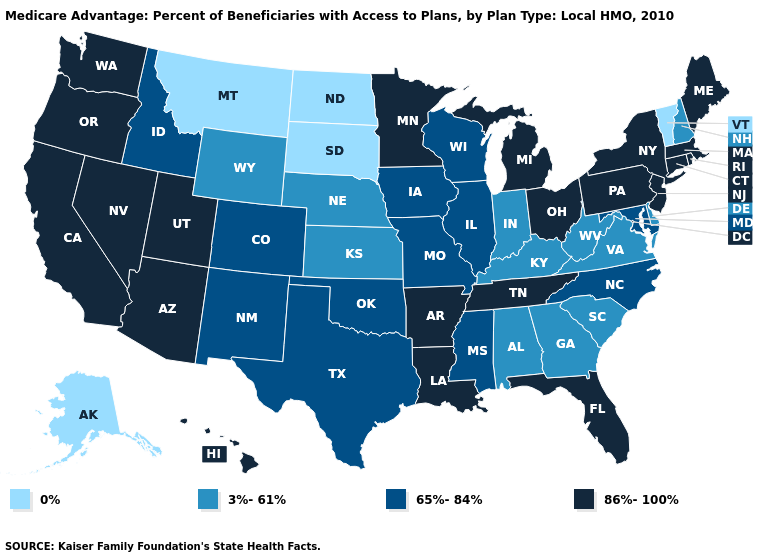Does Kansas have the lowest value in the MidWest?
Answer briefly. No. What is the highest value in states that border Rhode Island?
Quick response, please. 86%-100%. Does Kentucky have the same value as Iowa?
Write a very short answer. No. What is the value of Delaware?
Be succinct. 3%-61%. How many symbols are there in the legend?
Keep it brief. 4. Is the legend a continuous bar?
Quick response, please. No. Which states hav the highest value in the MidWest?
Short answer required. Michigan, Minnesota, Ohio. Name the states that have a value in the range 3%-61%?
Short answer required. Alabama, Delaware, Georgia, Indiana, Kansas, Kentucky, Nebraska, New Hampshire, South Carolina, Virginia, West Virginia, Wyoming. Which states have the highest value in the USA?
Write a very short answer. Arkansas, Arizona, California, Connecticut, Florida, Hawaii, Louisiana, Massachusetts, Maine, Michigan, Minnesota, New Jersey, Nevada, New York, Ohio, Oregon, Pennsylvania, Rhode Island, Tennessee, Utah, Washington. What is the value of Maine?
Give a very brief answer. 86%-100%. What is the value of Vermont?
Give a very brief answer. 0%. What is the value of Alaska?
Write a very short answer. 0%. Does Arizona have a higher value than South Carolina?
Concise answer only. Yes. Among the states that border Virginia , which have the highest value?
Answer briefly. Tennessee. 